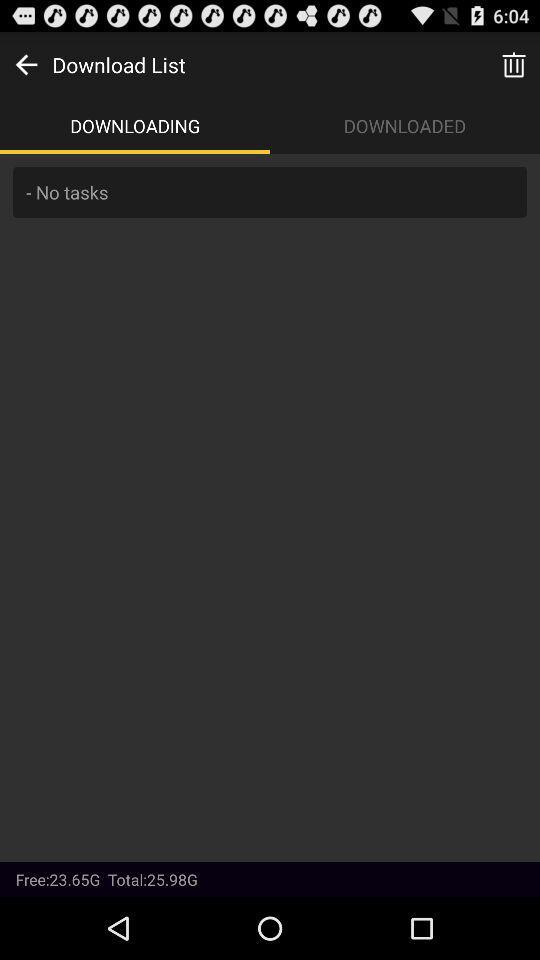What is the total storage? The total storage is 25.98 G. 